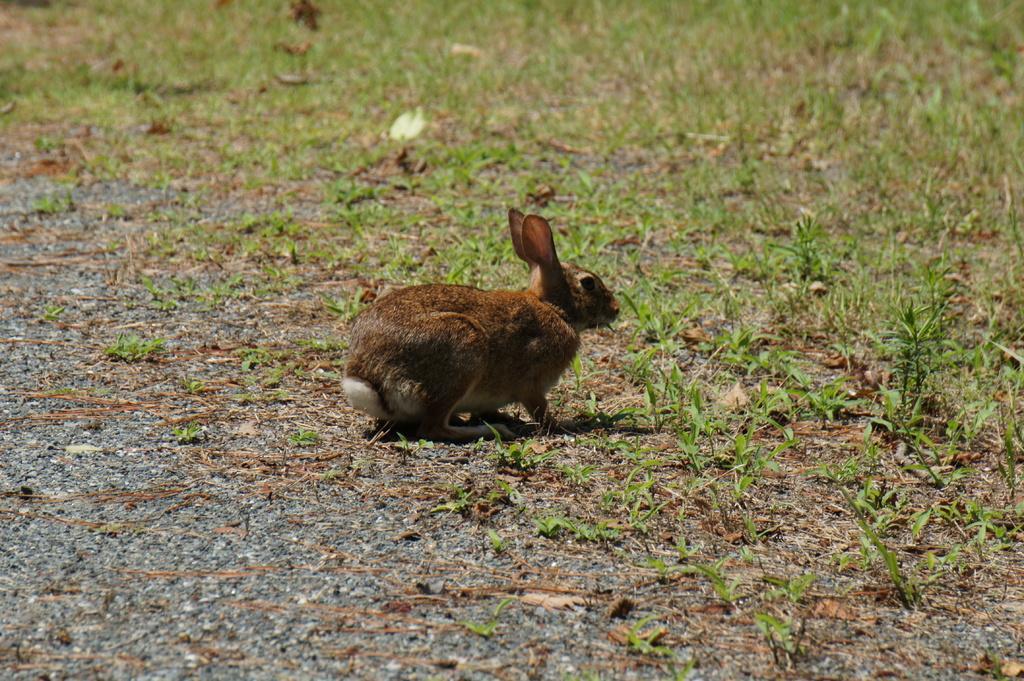How would you summarize this image in a sentence or two? In this picture I can observe rabbit in the middle of the picture. It is in brown color. I can observe some grass on the ground. 